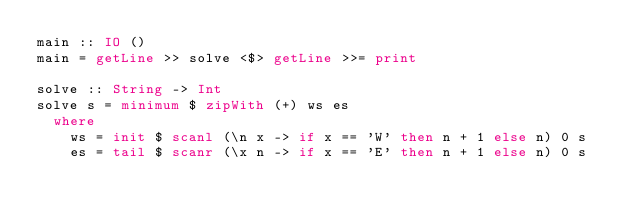Convert code to text. <code><loc_0><loc_0><loc_500><loc_500><_Haskell_>main :: IO ()
main = getLine >> solve <$> getLine >>= print

solve :: String -> Int
solve s = minimum $ zipWith (+) ws es
  where
    ws = init $ scanl (\n x -> if x == 'W' then n + 1 else n) 0 s
    es = tail $ scanr (\x n -> if x == 'E' then n + 1 else n) 0 s</code> 